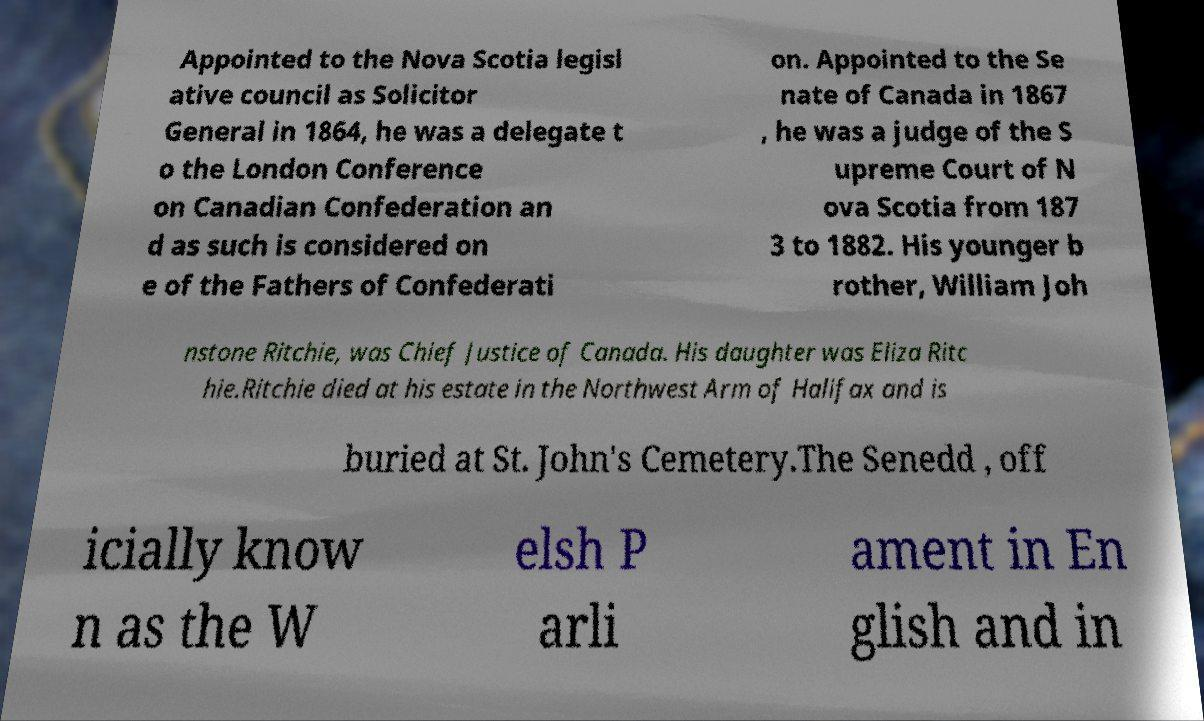For documentation purposes, I need the text within this image transcribed. Could you provide that? Appointed to the Nova Scotia legisl ative council as Solicitor General in 1864, he was a delegate t o the London Conference on Canadian Confederation an d as such is considered on e of the Fathers of Confederati on. Appointed to the Se nate of Canada in 1867 , he was a judge of the S upreme Court of N ova Scotia from 187 3 to 1882. His younger b rother, William Joh nstone Ritchie, was Chief Justice of Canada. His daughter was Eliza Ritc hie.Ritchie died at his estate in the Northwest Arm of Halifax and is buried at St. John's Cemetery.The Senedd , off icially know n as the W elsh P arli ament in En glish and in 